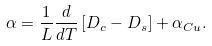<formula> <loc_0><loc_0><loc_500><loc_500>\ \alpha = \frac { 1 } { L } \frac { d } { d T } \left [ { D _ { c } - D _ { s } } \right ] + \alpha _ { C u } . \</formula> 